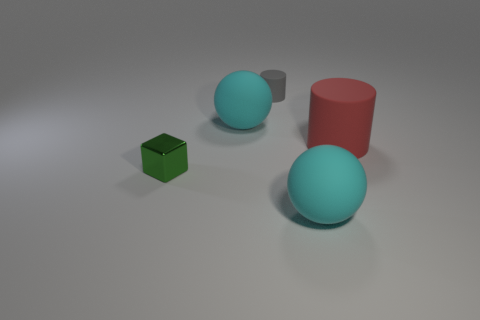Are there any green objects of the same size as the gray rubber thing?
Make the answer very short. Yes. Do the large ball behind the green object and the tiny green object have the same material?
Your answer should be compact. No. Is the number of cylinders on the left side of the small green metallic object the same as the number of red things right of the big matte cylinder?
Provide a short and direct response. Yes. There is a thing that is on the left side of the small matte cylinder and on the right side of the block; what shape is it?
Your answer should be compact. Sphere. What number of large rubber things are on the right side of the tiny matte thing?
Offer a very short reply. 2. What number of other objects are there of the same shape as the green metal thing?
Ensure brevity in your answer.  0. Is the number of gray matte objects less than the number of big cyan rubber cubes?
Your answer should be very brief. No. There is a object that is both left of the gray cylinder and in front of the large red rubber thing; what size is it?
Provide a succinct answer. Small. There is a cyan matte ball that is to the right of the big cyan sphere that is to the left of the big cyan ball that is in front of the small block; what size is it?
Keep it short and to the point. Large. The red rubber cylinder has what size?
Offer a very short reply. Large. 